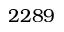Convert formula to latex. <formula><loc_0><loc_0><loc_500><loc_500>2 2 8 9</formula> 